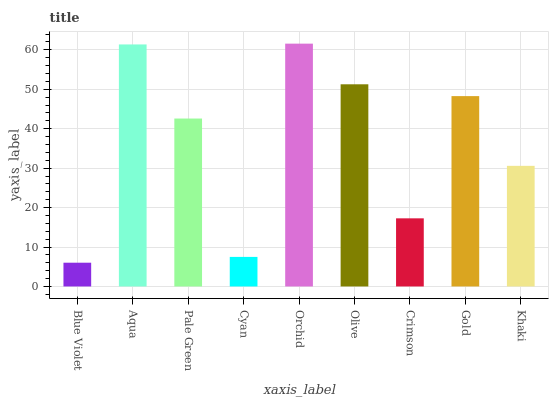Is Blue Violet the minimum?
Answer yes or no. Yes. Is Orchid the maximum?
Answer yes or no. Yes. Is Aqua the minimum?
Answer yes or no. No. Is Aqua the maximum?
Answer yes or no. No. Is Aqua greater than Blue Violet?
Answer yes or no. Yes. Is Blue Violet less than Aqua?
Answer yes or no. Yes. Is Blue Violet greater than Aqua?
Answer yes or no. No. Is Aqua less than Blue Violet?
Answer yes or no. No. Is Pale Green the high median?
Answer yes or no. Yes. Is Pale Green the low median?
Answer yes or no. Yes. Is Aqua the high median?
Answer yes or no. No. Is Blue Violet the low median?
Answer yes or no. No. 